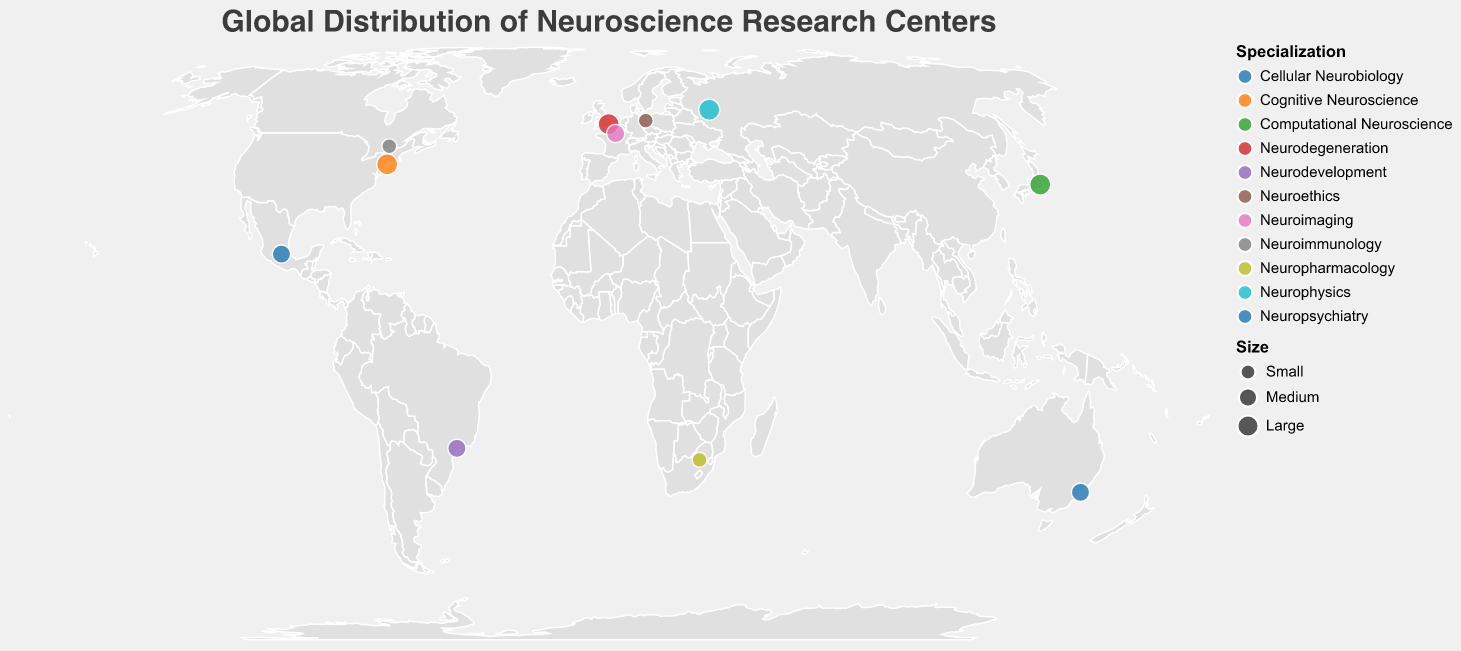What is the title of the figure? The title of a figure is usually displayed prominently at the top. In this case, the title is present in the code as "Global Distribution of Neuroscience Research Centers".
Answer: Global Distribution of Neuroscience Research Centers Which research center specializes in Neuropsychology and where is it located? By looking at the visual representation focusing on `Specialization` and `Location`, one can identify that none of the centers listed specializes in Neuropsychology. Instead, a related field, Neuropsychiatry, is specialized by the Brain and Mind Centre located in Australia.
Answer: Brain and Mind Centre, Australia How many neuroscience research centers are classified as 'Large' by size? The data includes size information, where circles representing 'Large' research centers have a larger diameter. Counting these, one can see there are four: UCL Queen Square Institute of Neurology, NYU Neuroscience Institute, RIKEN Center for Brain Science, and the Kurchatov Institute.
Answer: 4 Which country hosts the research center focusing on "Neurodegeneration"? Using the tooltips and the color code for specialization, the UCL Queen Square Institute of Neurology in the UK is the center focused on Neurodegeneration.
Answer: UK Compare the number of comprehensive research centers focusing on Cognitive Neuroscience versus Neuroimaging. Which is more? According to the visual, there is one center for Cognitive Neuroscience (NYU Neuroscience Institute) and one center for Neuroimaging (Institut du Cerveau et de la Moelle épinière). So, they are equal in number.
Answer: Equal Which research specialization in the figure is unique to only one research center? By examining the unique specializations given for each center, "Neuroethics" is only found at the Berlin School of Mind and Brain.
Answer: Neuroethics How many research centers are located in the Southern Hemisphere? Centers located in the Southern Hemisphere have a latitude less than 0. Identifying these from the plot, there are three: Brain and Mind Centre in Australia, Brain Institute of Rio Grande do Sul in Brazil, and Brain Function Research Group in South Africa.
Answer: 3 What is the general geographic distribution pattern of the research centers? The research centers are broadly spread across different continents: North America, South America, Europe, Asia, and Australia, demonstrating a global spread with no significant clustering in any one area.
Answer: Globally spread Which continent has the highest number of neuroscience research centers represented in the figure? By counting the number of research centers in each continent, Europe has three (UK, France, Germany), making it the highest.
Answer: Europe 